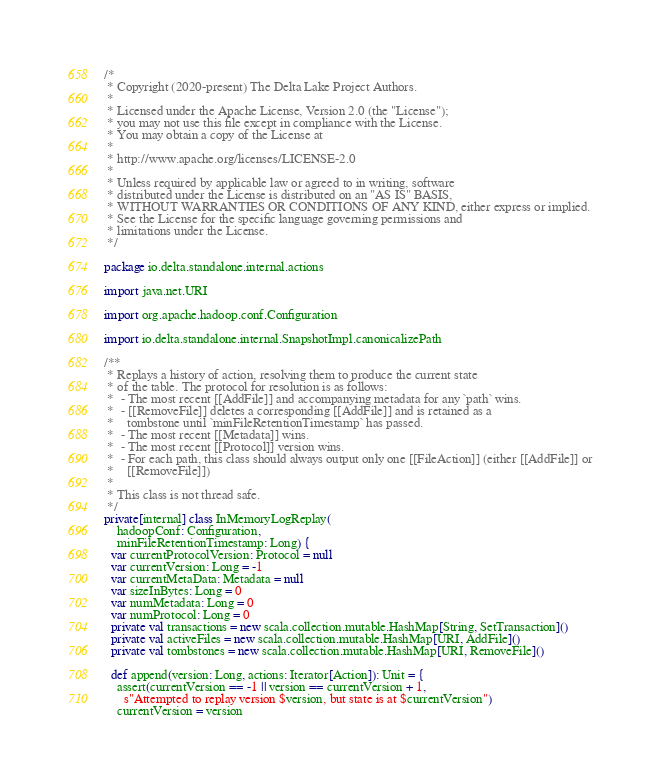Convert code to text. <code><loc_0><loc_0><loc_500><loc_500><_Scala_>/*
 * Copyright (2020-present) The Delta Lake Project Authors.
 *
 * Licensed under the Apache License, Version 2.0 (the "License");
 * you may not use this file except in compliance with the License.
 * You may obtain a copy of the License at
 *
 * http://www.apache.org/licenses/LICENSE-2.0
 *
 * Unless required by applicable law or agreed to in writing, software
 * distributed under the License is distributed on an "AS IS" BASIS,
 * WITHOUT WARRANTIES OR CONDITIONS OF ANY KIND, either express or implied.
 * See the License for the specific language governing permissions and
 * limitations under the License.
 */

package io.delta.standalone.internal.actions

import java.net.URI

import org.apache.hadoop.conf.Configuration

import io.delta.standalone.internal.SnapshotImpl.canonicalizePath

/**
 * Replays a history of action, resolving them to produce the current state
 * of the table. The protocol for resolution is as follows:
 *  - The most recent [[AddFile]] and accompanying metadata for any `path` wins.
 *  - [[RemoveFile]] deletes a corresponding [[AddFile]] and is retained as a
 *    tombstone until `minFileRetentionTimestamp` has passed.
 *  - The most recent [[Metadata]] wins.
 *  - The most recent [[Protocol]] version wins.
 *  - For each path, this class should always output only one [[FileAction]] (either [[AddFile]] or
 *    [[RemoveFile]])
 *
 * This class is not thread safe.
 */
private[internal] class InMemoryLogReplay(
    hadoopConf: Configuration,
    minFileRetentionTimestamp: Long) {
  var currentProtocolVersion: Protocol = null
  var currentVersion: Long = -1
  var currentMetaData: Metadata = null
  var sizeInBytes: Long = 0
  var numMetadata: Long = 0
  var numProtocol: Long = 0
  private val transactions = new scala.collection.mutable.HashMap[String, SetTransaction]()
  private val activeFiles = new scala.collection.mutable.HashMap[URI, AddFile]()
  private val tombstones = new scala.collection.mutable.HashMap[URI, RemoveFile]()

  def append(version: Long, actions: Iterator[Action]): Unit = {
    assert(currentVersion == -1 || version == currentVersion + 1,
      s"Attempted to replay version $version, but state is at $currentVersion")
    currentVersion = version</code> 